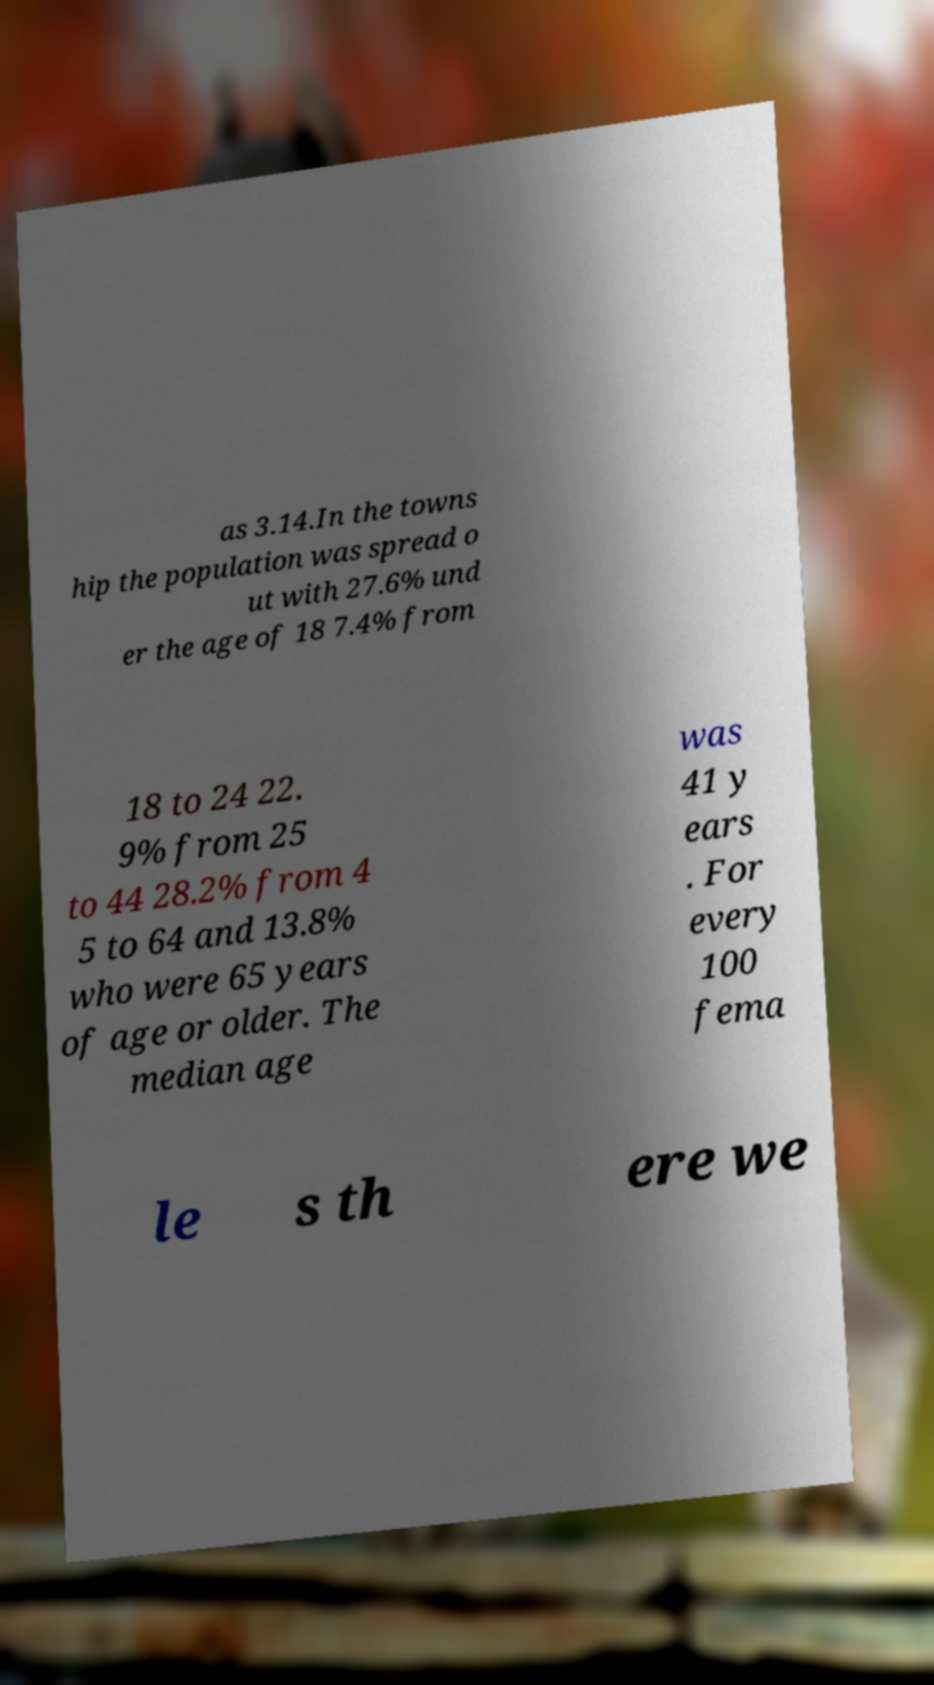Please identify and transcribe the text found in this image. as 3.14.In the towns hip the population was spread o ut with 27.6% und er the age of 18 7.4% from 18 to 24 22. 9% from 25 to 44 28.2% from 4 5 to 64 and 13.8% who were 65 years of age or older. The median age was 41 y ears . For every 100 fema le s th ere we 